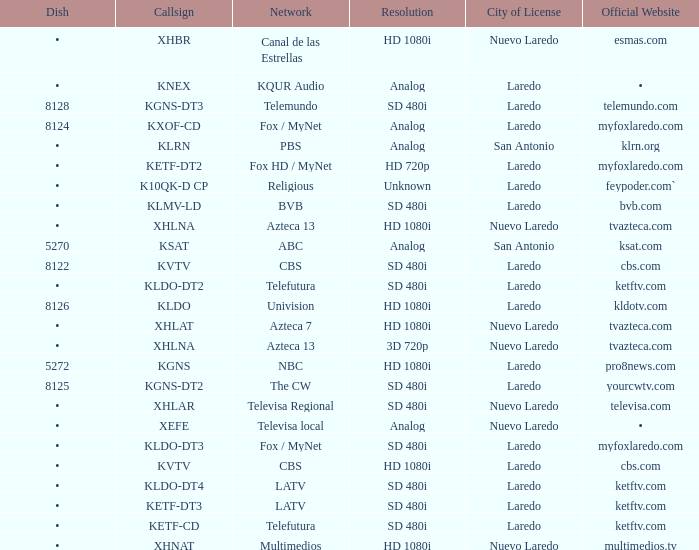Name the resolution with dish of 8126 HD 1080i. 